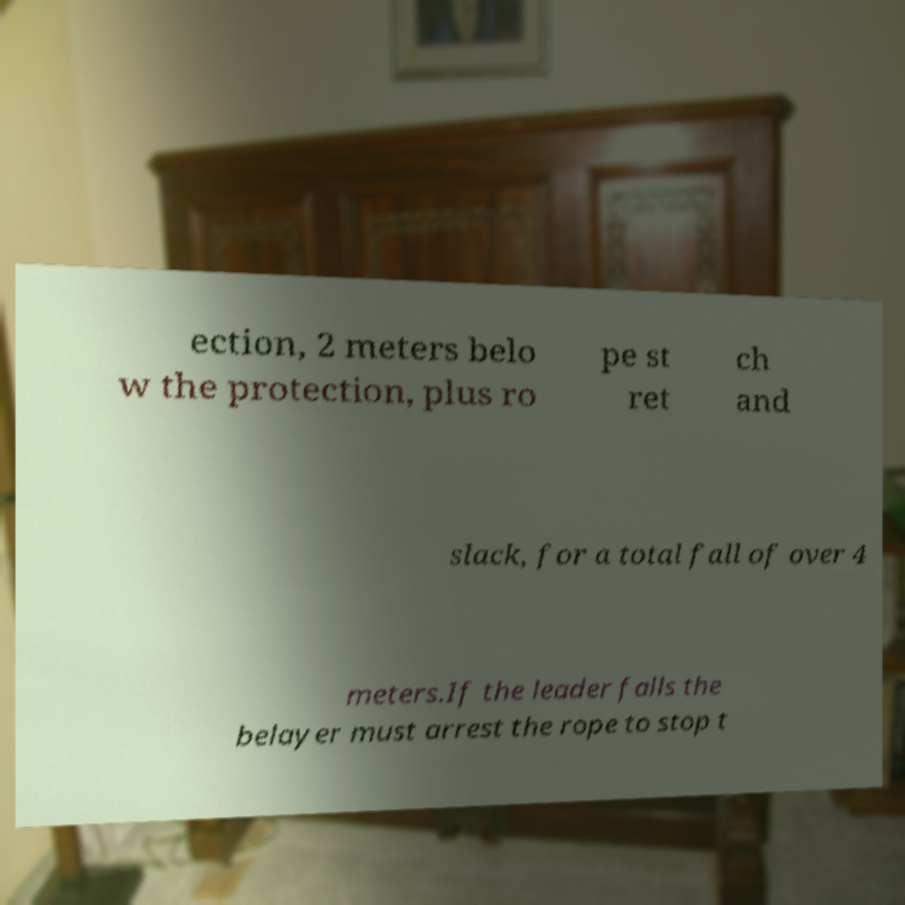Could you assist in decoding the text presented in this image and type it out clearly? ection, 2 meters belo w the protection, plus ro pe st ret ch and slack, for a total fall of over 4 meters.If the leader falls the belayer must arrest the rope to stop t 